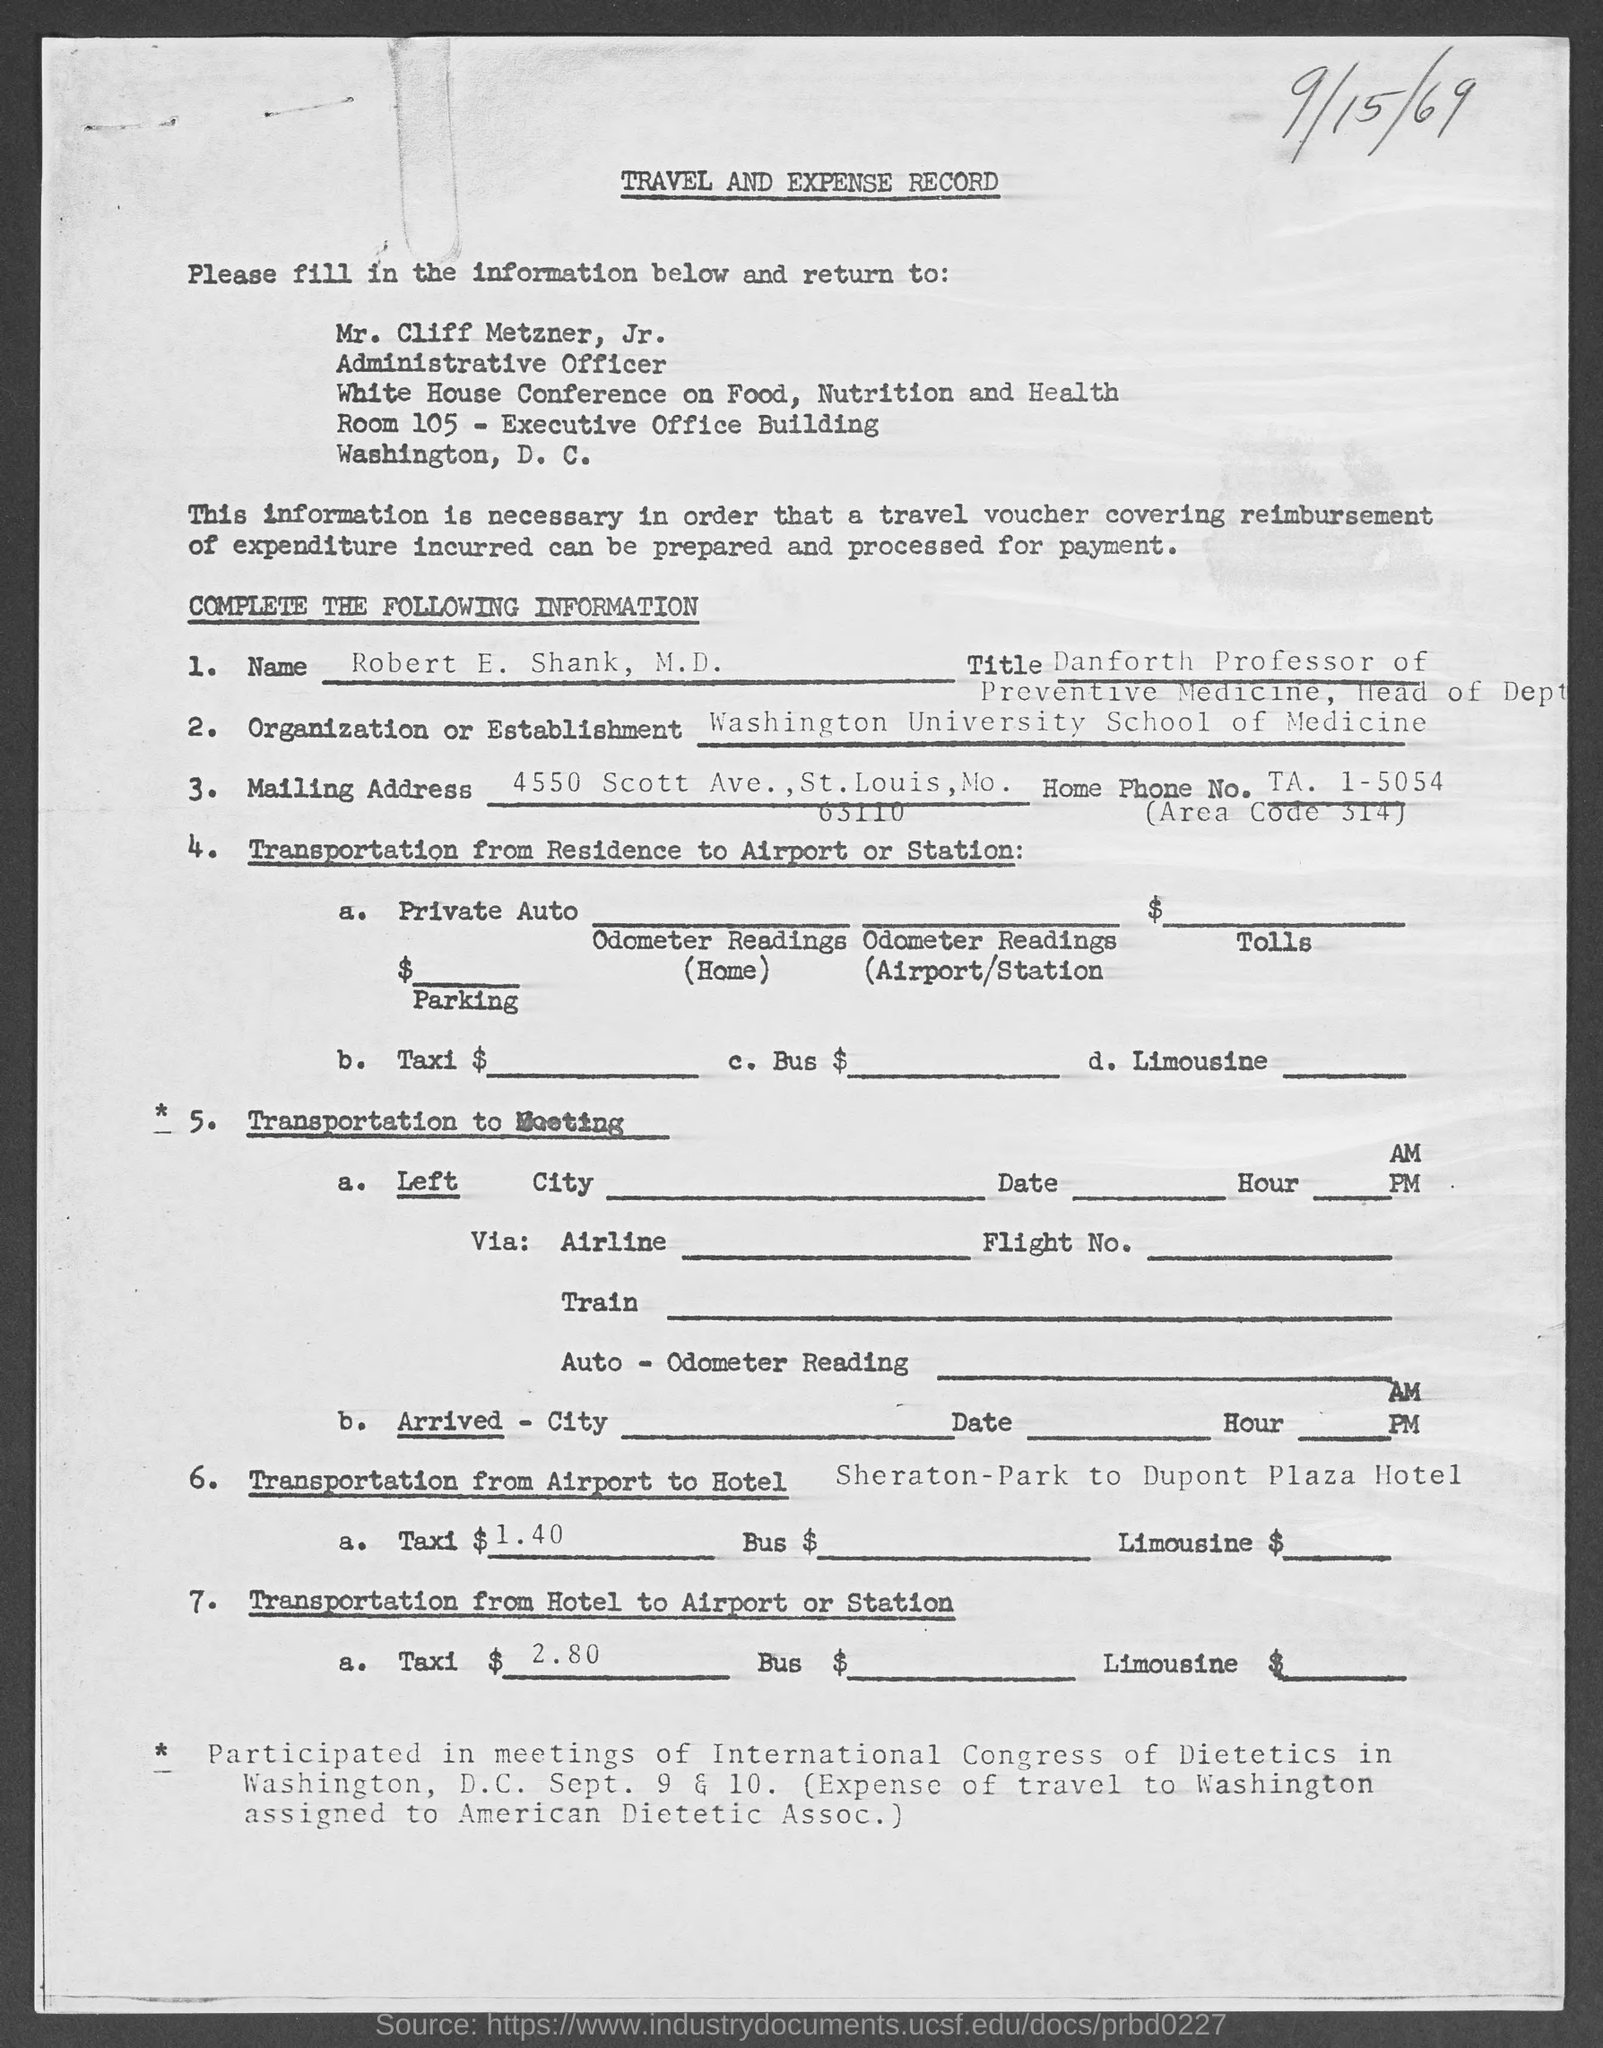What is the position of mr. cliff metzner, jr.?
Make the answer very short. Administrative officer. What is the name of applicant ?
Give a very brief answer. Robert E. Shank, M.D. 